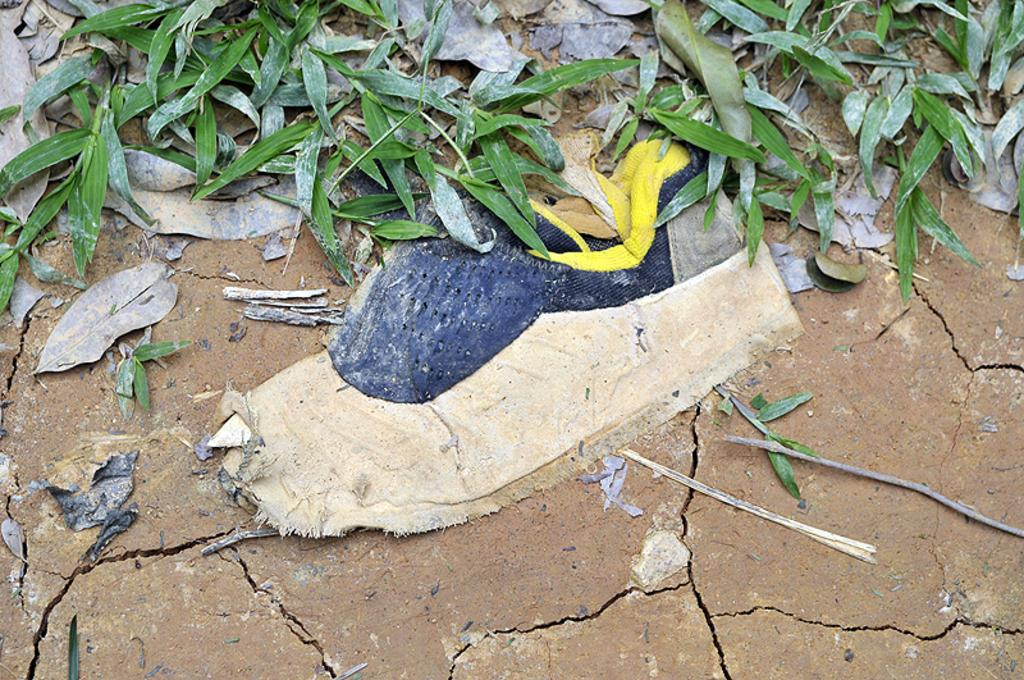What type of vegetation is present at the top of the image? There are dry leaves and grass at the top of the image. What else can be seen at the top of the image besides vegetation? There are other objects at the top of the image. What is the wooden object in the center of the image? There is a wooden object in the center of the image. What type of terrain is visible at the bottom of the image? There is dry land at the bottom of the image. Can you see any veins in the image? There are no veins visible in the image. What causes the leaves to fall in the image? The image does not show any leaves falling, so it is not possible to determine the cause. 